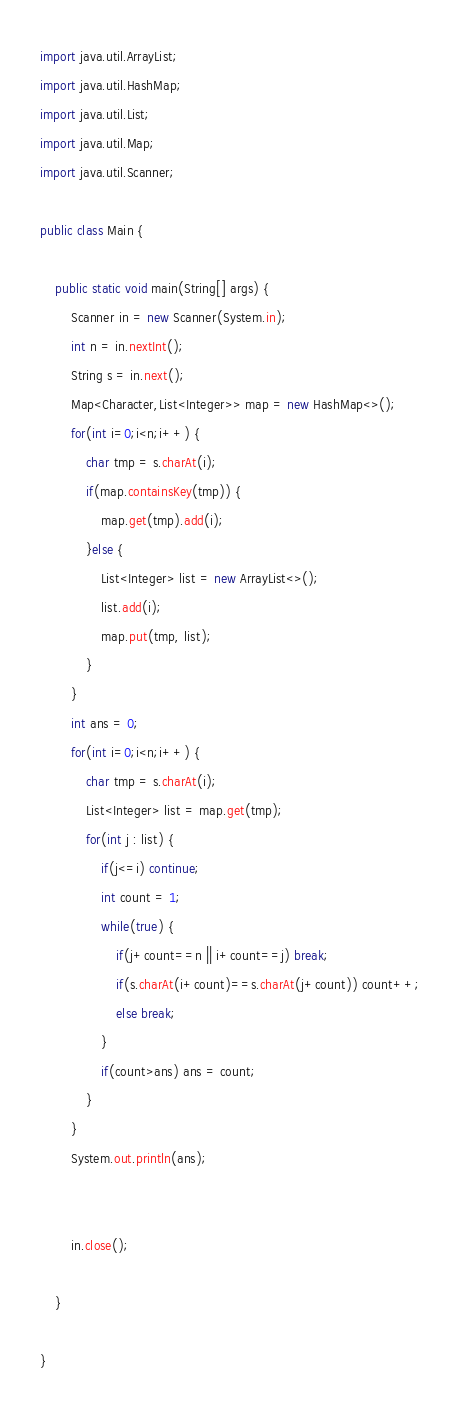<code> <loc_0><loc_0><loc_500><loc_500><_Java_>import java.util.ArrayList;
import java.util.HashMap;
import java.util.List;
import java.util.Map;
import java.util.Scanner;

public class Main {

	public static void main(String[] args) {
		Scanner in = new Scanner(System.in);
		int n = in.nextInt();
		String s = in.next();
		Map<Character,List<Integer>> map = new HashMap<>();
		for(int i=0;i<n;i++) {
			char tmp = s.charAt(i);
			if(map.containsKey(tmp)) {
				map.get(tmp).add(i);
			}else {
				List<Integer> list = new ArrayList<>();
				list.add(i);
				map.put(tmp, list);
			}
		}
		int ans = 0;
		for(int i=0;i<n;i++) {
			char tmp = s.charAt(i);
			List<Integer> list = map.get(tmp);
			for(int j : list) {
				if(j<=i) continue;
				int count = 1;
				while(true) {
					if(j+count==n || i+count==j) break;
					if(s.charAt(i+count)==s.charAt(j+count)) count++;
					else break;
				}
				if(count>ans) ans = count;
			}
		}
		System.out.println(ans);
		
		
		in.close();

	}

}
</code> 